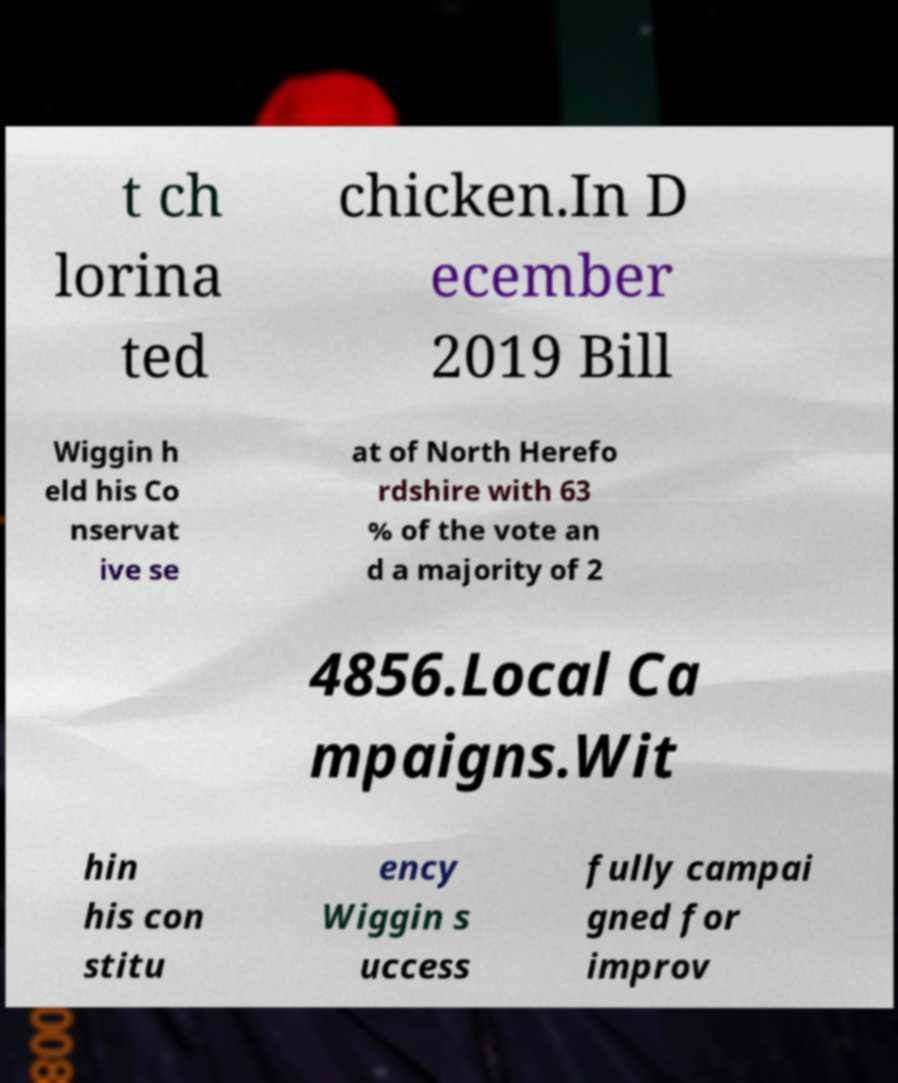Could you assist in decoding the text presented in this image and type it out clearly? t ch lorina ted chicken.In D ecember 2019 Bill Wiggin h eld his Co nservat ive se at of North Herefo rdshire with 63 % of the vote an d a majority of 2 4856.Local Ca mpaigns.Wit hin his con stitu ency Wiggin s uccess fully campai gned for improv 